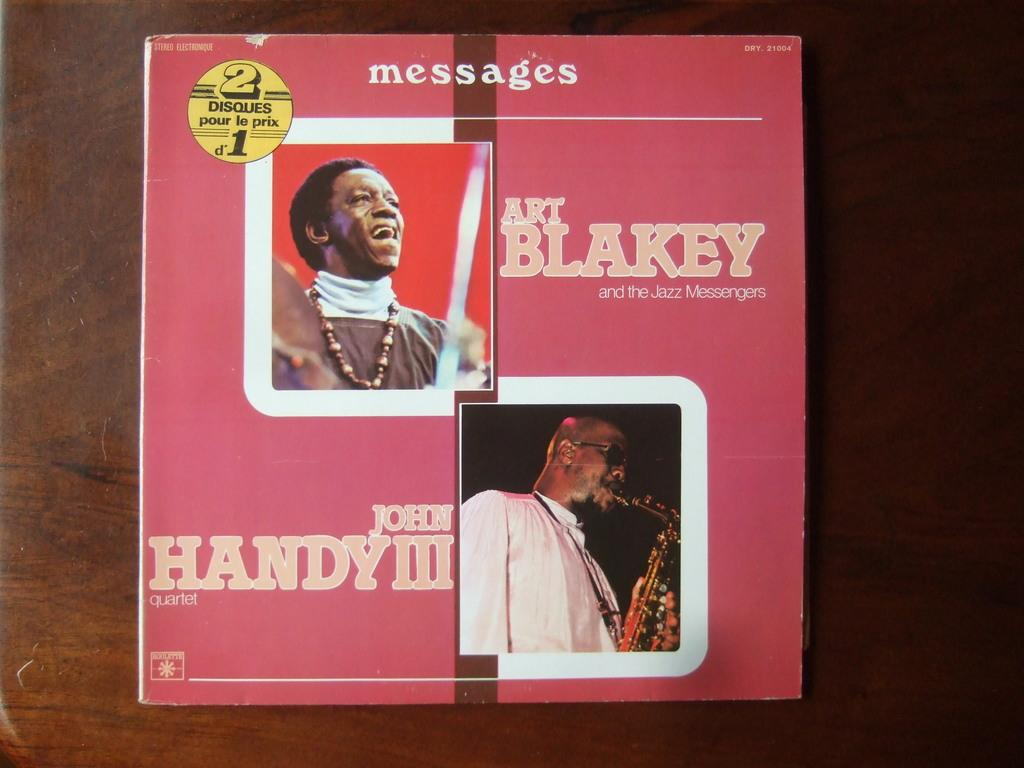<image>
Provide a brief description of the given image. Art Blakey and John Handy are listed on this double album cover. 